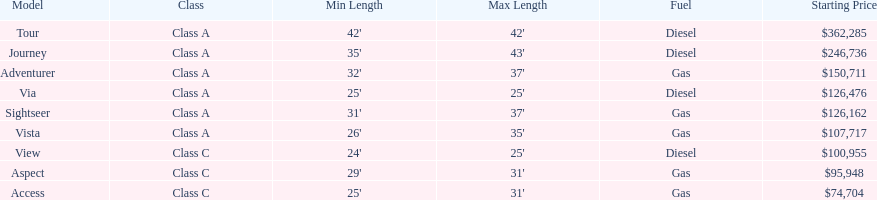How long is the aspect? 29'-31'. 